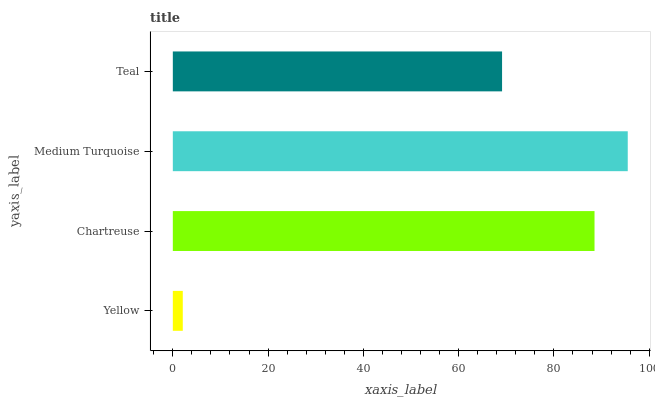Is Yellow the minimum?
Answer yes or no. Yes. Is Medium Turquoise the maximum?
Answer yes or no. Yes. Is Chartreuse the minimum?
Answer yes or no. No. Is Chartreuse the maximum?
Answer yes or no. No. Is Chartreuse greater than Yellow?
Answer yes or no. Yes. Is Yellow less than Chartreuse?
Answer yes or no. Yes. Is Yellow greater than Chartreuse?
Answer yes or no. No. Is Chartreuse less than Yellow?
Answer yes or no. No. Is Chartreuse the high median?
Answer yes or no. Yes. Is Teal the low median?
Answer yes or no. Yes. Is Teal the high median?
Answer yes or no. No. Is Yellow the low median?
Answer yes or no. No. 